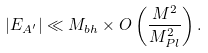Convert formula to latex. <formula><loc_0><loc_0><loc_500><loc_500>| E _ { A ^ { \prime } } | \ll M _ { b h } \times O \left ( \frac { M ^ { 2 } } { M _ { P l } ^ { 2 } } \right ) .</formula> 